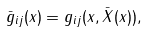<formula> <loc_0><loc_0><loc_500><loc_500>\bar { g } _ { i j } ( x ) = g _ { i j } ( x , \bar { X } ( x ) ) ,</formula> 